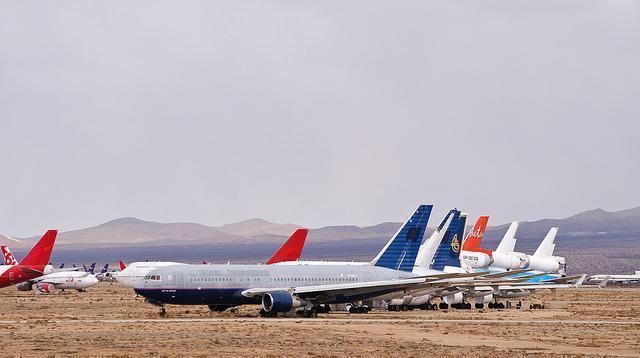What is the blue back piece of the plane called?
Pick the right solution, then justify: 'Answer: answer
Rationale: rationale.'
Options: Fuselage, rotor, tail pipe, fin. Answer: fin.
Rationale: The triangular upwards facing extension in the rear of these planes are called fins. 